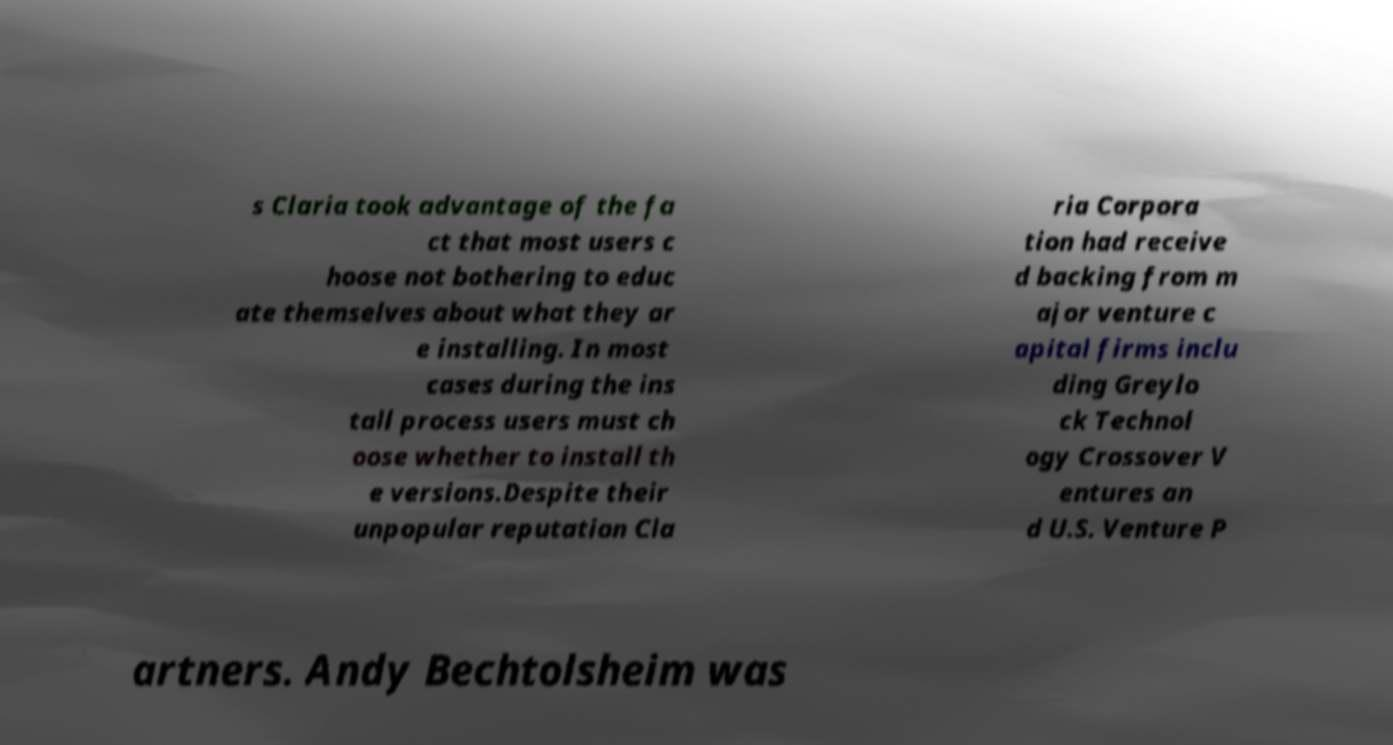Can you accurately transcribe the text from the provided image for me? s Claria took advantage of the fa ct that most users c hoose not bothering to educ ate themselves about what they ar e installing. In most cases during the ins tall process users must ch oose whether to install th e versions.Despite their unpopular reputation Cla ria Corpora tion had receive d backing from m ajor venture c apital firms inclu ding Greylo ck Technol ogy Crossover V entures an d U.S. Venture P artners. Andy Bechtolsheim was 